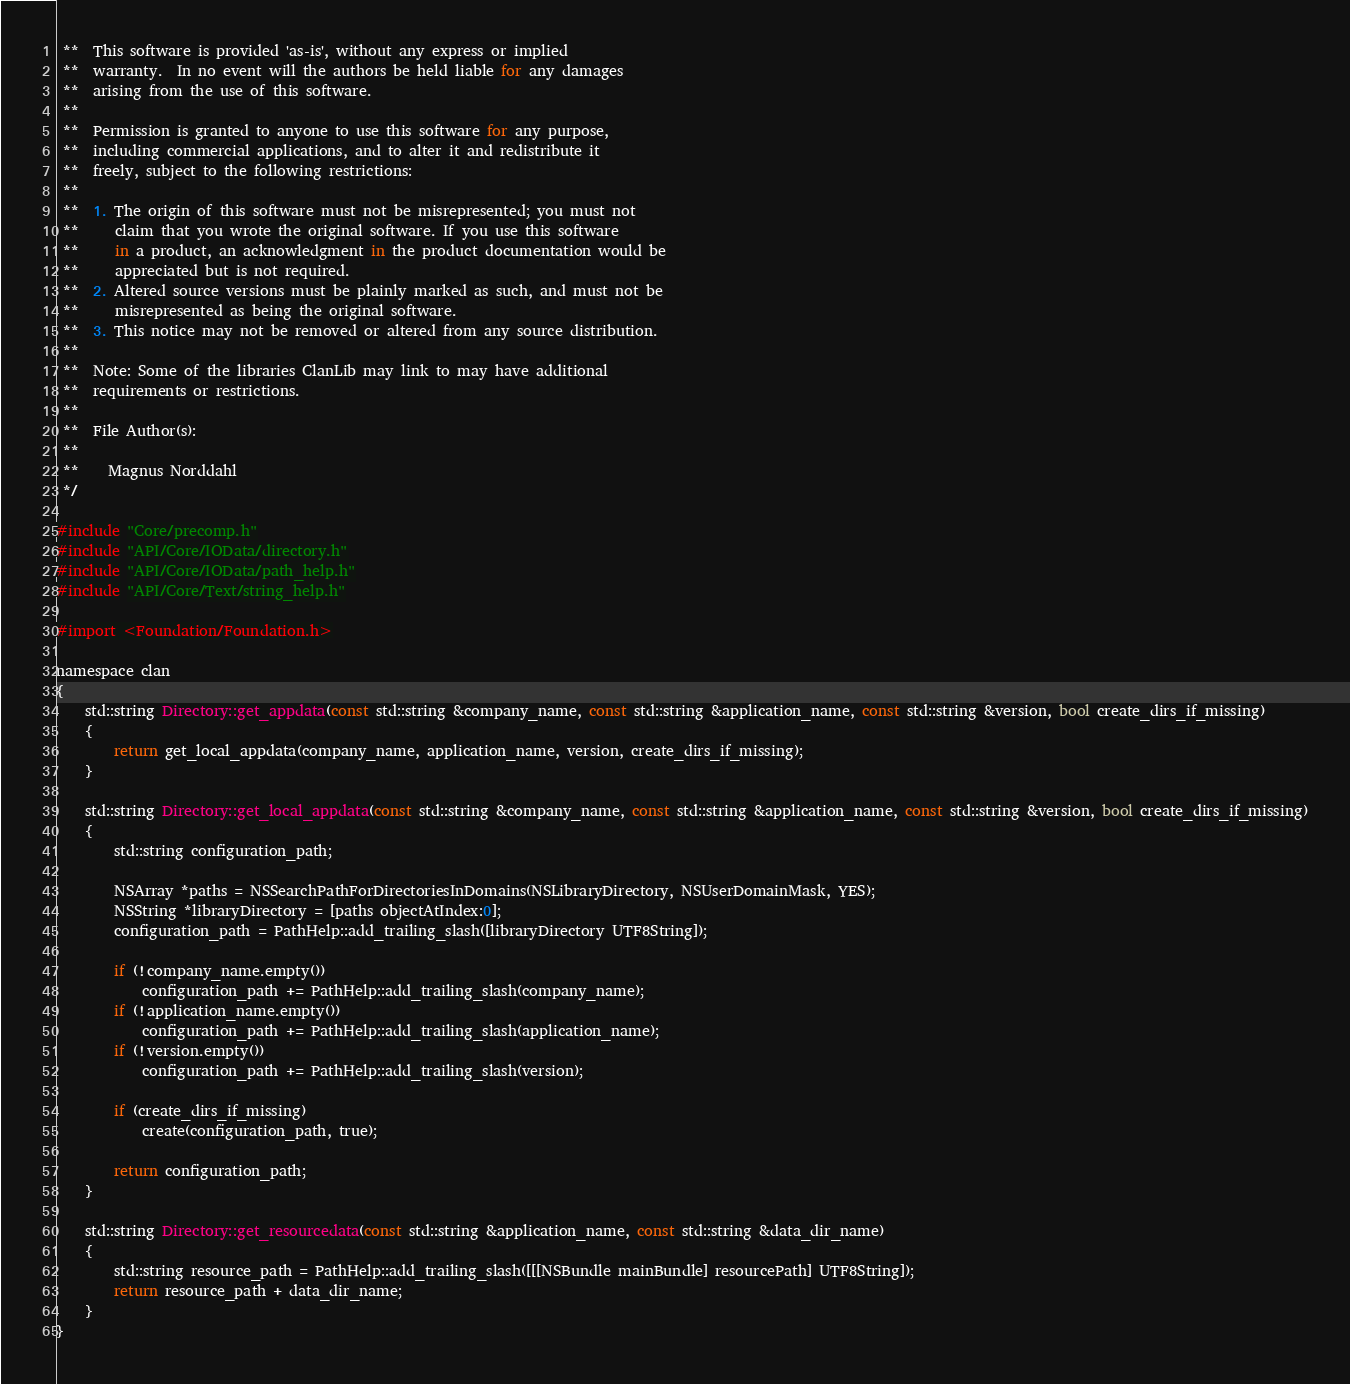Convert code to text. <code><loc_0><loc_0><loc_500><loc_500><_ObjectiveC_> **  This software is provided 'as-is', without any express or implied
 **  warranty.  In no event will the authors be held liable for any damages
 **  arising from the use of this software.
 **
 **  Permission is granted to anyone to use this software for any purpose,
 **  including commercial applications, and to alter it and redistribute it
 **  freely, subject to the following restrictions:
 **
 **  1. The origin of this software must not be misrepresented; you must not
 **     claim that you wrote the original software. If you use this software
 **     in a product, an acknowledgment in the product documentation would be
 **     appreciated but is not required.
 **  2. Altered source versions must be plainly marked as such, and must not be
 **     misrepresented as being the original software.
 **  3. This notice may not be removed or altered from any source distribution.
 **
 **  Note: Some of the libraries ClanLib may link to may have additional
 **  requirements or restrictions.
 **
 **  File Author(s):
 **
 **    Magnus Norddahl
 */

#include "Core/precomp.h"
#include "API/Core/IOData/directory.h"
#include "API/Core/IOData/path_help.h"
#include "API/Core/Text/string_help.h"

#import <Foundation/Foundation.h>

namespace clan
{
	std::string Directory::get_appdata(const std::string &company_name, const std::string &application_name, const std::string &version, bool create_dirs_if_missing)
	{
		return get_local_appdata(company_name, application_name, version, create_dirs_if_missing);
	}
	
	std::string Directory::get_local_appdata(const std::string &company_name, const std::string &application_name, const std::string &version, bool create_dirs_if_missing)
	{
		std::string configuration_path;
		
		NSArray *paths = NSSearchPathForDirectoriesInDomains(NSLibraryDirectory, NSUserDomainMask, YES);
		NSString *libraryDirectory = [paths objectAtIndex:0];
		configuration_path = PathHelp::add_trailing_slash([libraryDirectory UTF8String]);
		
		if (!company_name.empty())
			configuration_path += PathHelp::add_trailing_slash(company_name);
		if (!application_name.empty())
			configuration_path += PathHelp::add_trailing_slash(application_name);
		if (!version.empty())
			configuration_path += PathHelp::add_trailing_slash(version);
		
		if (create_dirs_if_missing)
			create(configuration_path, true);
		
		return configuration_path;
	}
	
	std::string Directory::get_resourcedata(const std::string &application_name, const std::string &data_dir_name)
	{
		std::string resource_path = PathHelp::add_trailing_slash([[[NSBundle mainBundle] resourcePath] UTF8String]);
		return resource_path + data_dir_name;
	}
}
</code> 